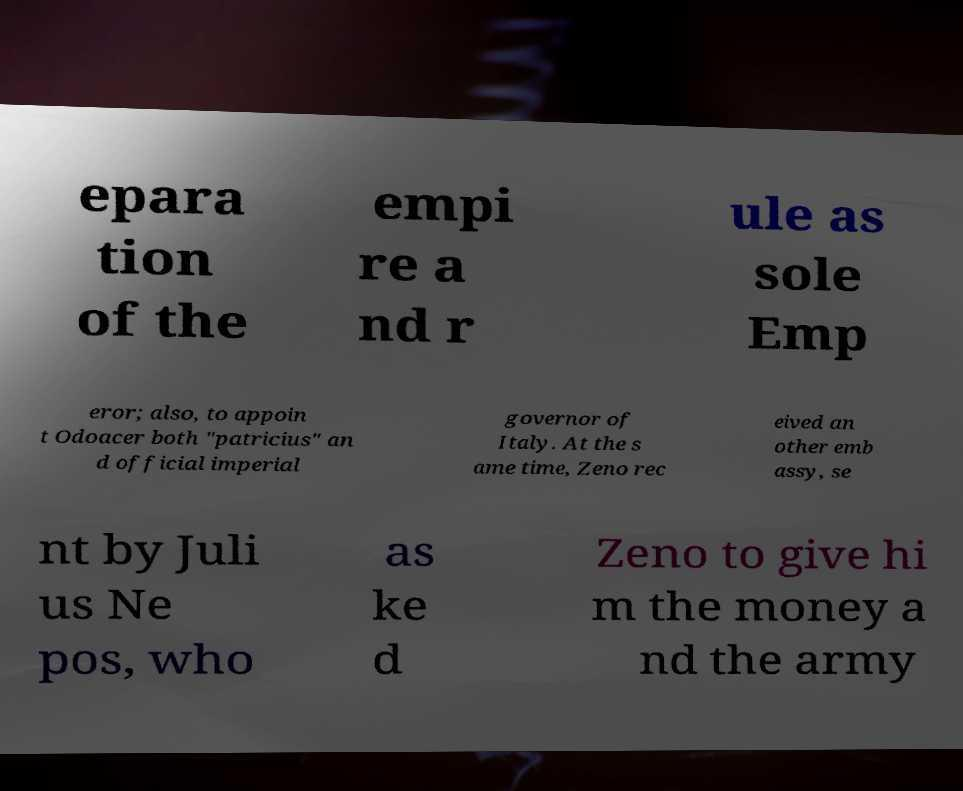Could you extract and type out the text from this image? epara tion of the empi re a nd r ule as sole Emp eror; also, to appoin t Odoacer both "patricius" an d official imperial governor of Italy. At the s ame time, Zeno rec eived an other emb assy, se nt by Juli us Ne pos, who as ke d Zeno to give hi m the money a nd the army 